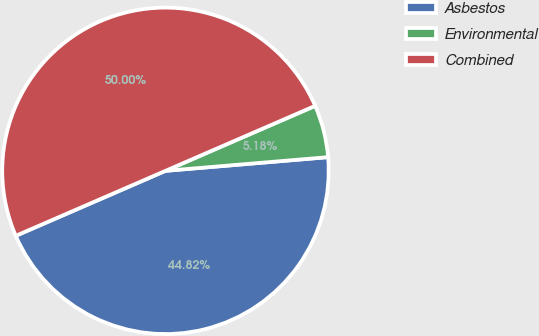Convert chart. <chart><loc_0><loc_0><loc_500><loc_500><pie_chart><fcel>Asbestos<fcel>Environmental<fcel>Combined<nl><fcel>44.82%<fcel>5.18%<fcel>50.0%<nl></chart> 